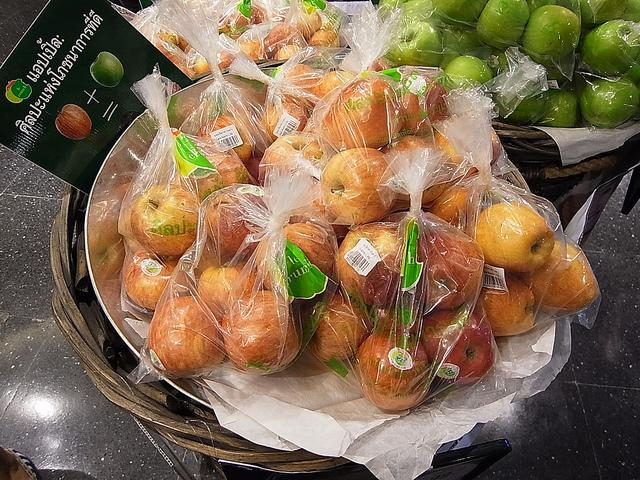What is the condition of these items?

Choices:
A) cooking
B) plated
C) wrapped
D) exposed wrapped 